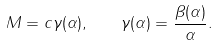Convert formula to latex. <formula><loc_0><loc_0><loc_500><loc_500>M = c \gamma ( \alpha ) , \quad \gamma ( \alpha ) = \frac { \beta ( \alpha ) } { \alpha } .</formula> 